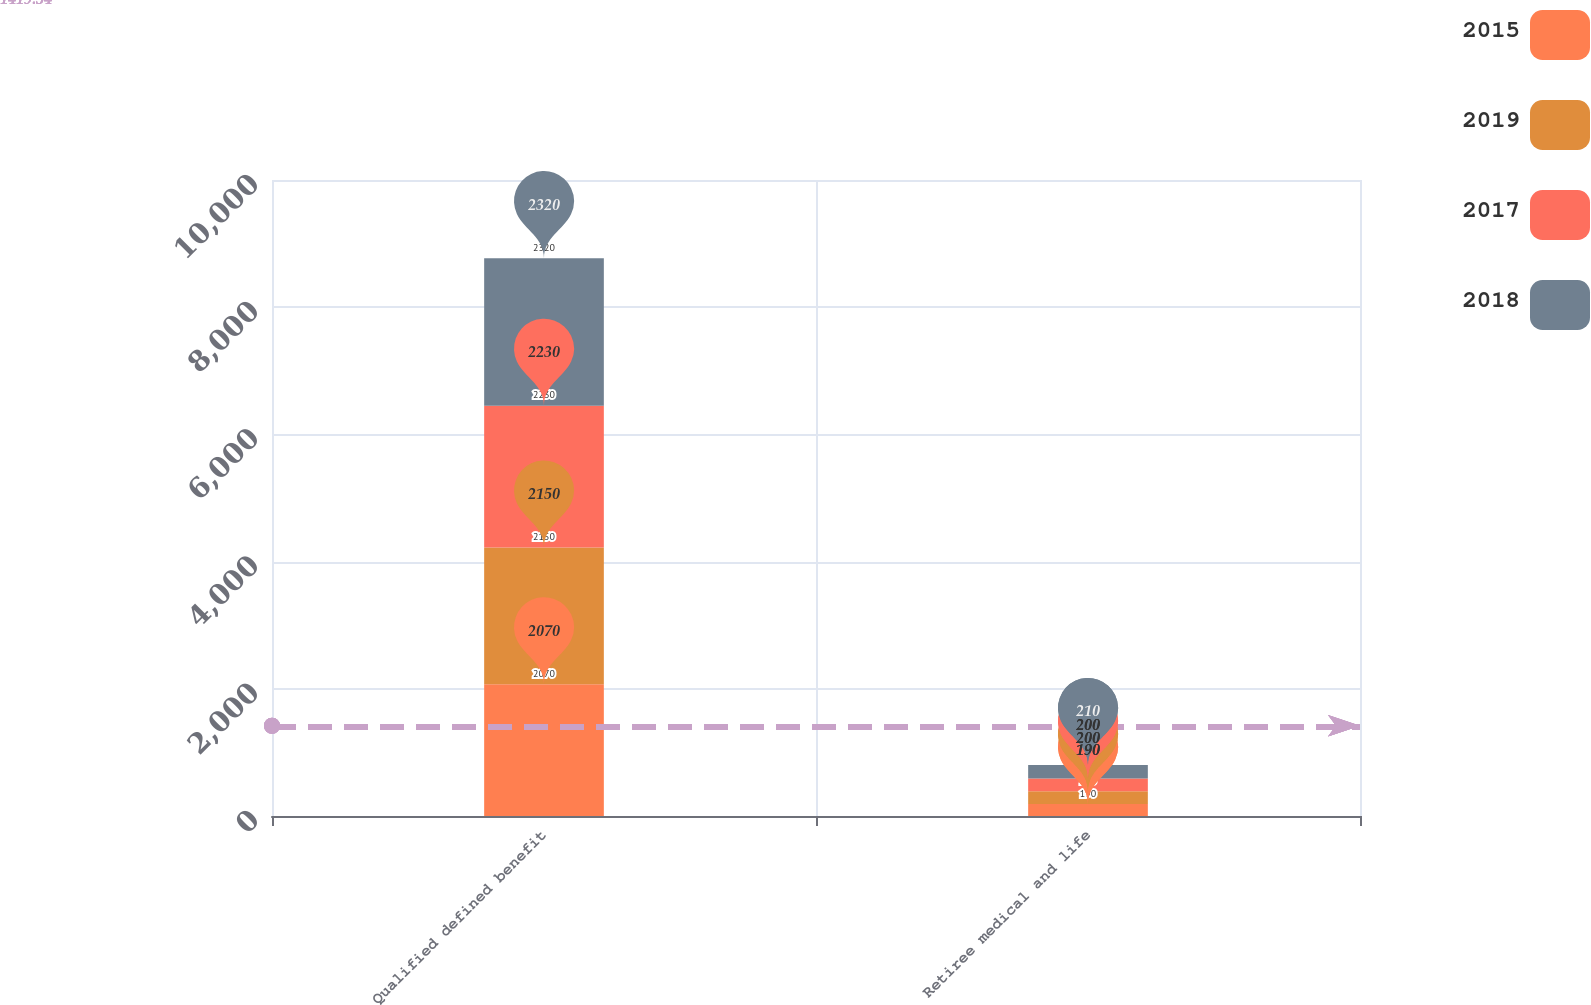Convert chart. <chart><loc_0><loc_0><loc_500><loc_500><stacked_bar_chart><ecel><fcel>Qualified defined benefit<fcel>Retiree medical and life<nl><fcel>2015<fcel>2070<fcel>190<nl><fcel>2019<fcel>2150<fcel>200<nl><fcel>2017<fcel>2230<fcel>200<nl><fcel>2018<fcel>2320<fcel>210<nl></chart> 